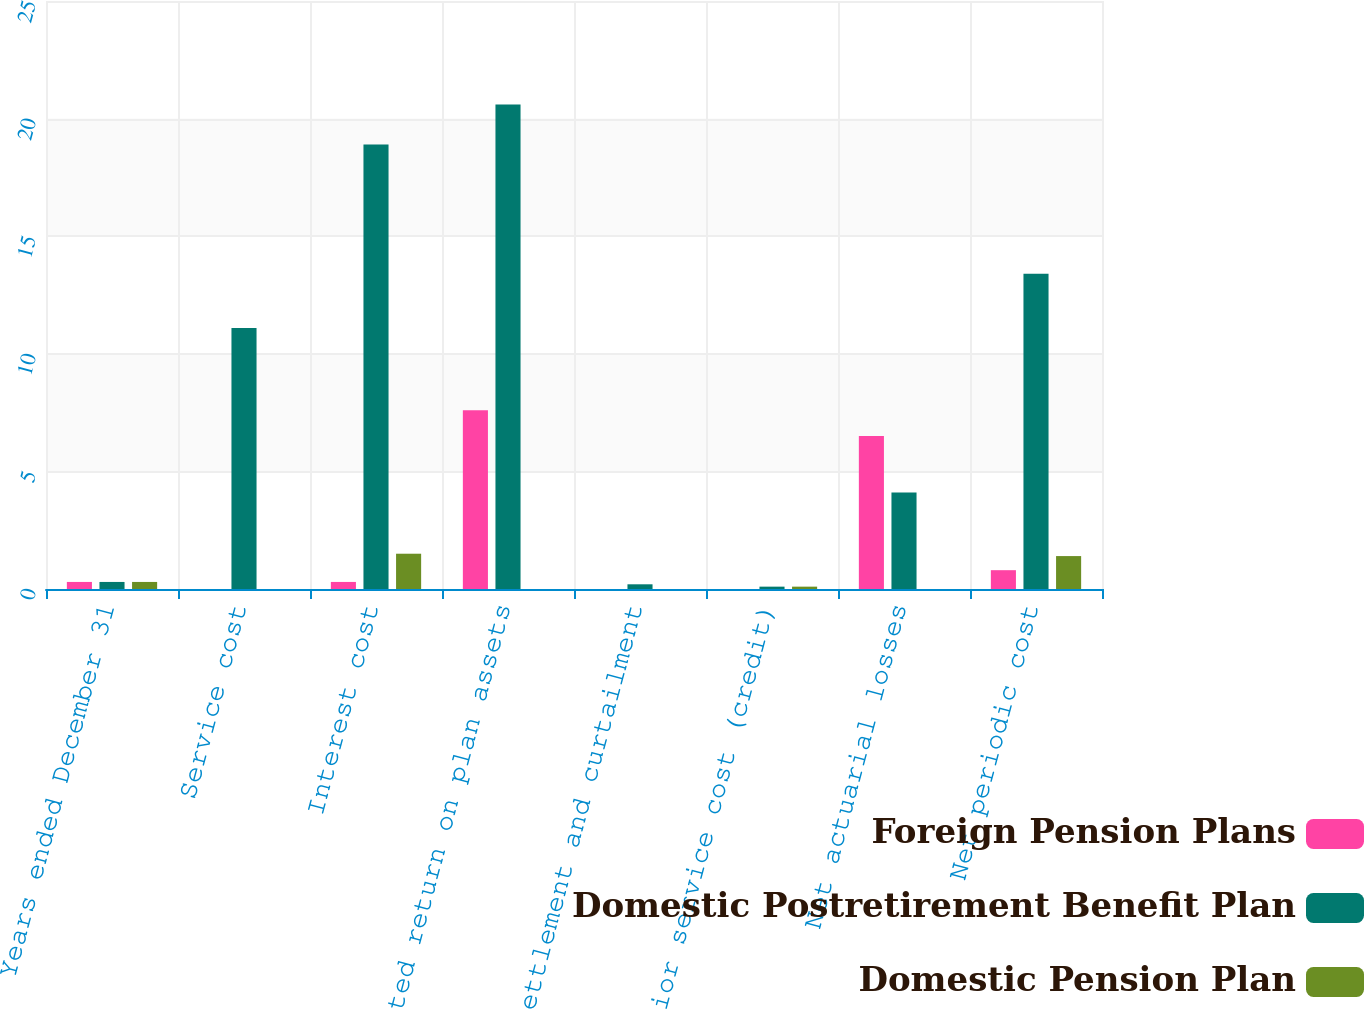<chart> <loc_0><loc_0><loc_500><loc_500><stacked_bar_chart><ecel><fcel>Years ended December 31<fcel>Service cost<fcel>Interest cost<fcel>Expected return on plan assets<fcel>Settlement and curtailment<fcel>Prior service cost (credit)<fcel>Net actuarial losses<fcel>Net periodic cost<nl><fcel>Foreign Pension Plans<fcel>0.3<fcel>0<fcel>0.3<fcel>7.6<fcel>0<fcel>0<fcel>6.5<fcel>0.8<nl><fcel>Domestic Postretirement Benefit Plan<fcel>0.3<fcel>11.1<fcel>18.9<fcel>20.6<fcel>0.2<fcel>0.1<fcel>4.1<fcel>13.4<nl><fcel>Domestic Pension Plan<fcel>0.3<fcel>0<fcel>1.5<fcel>0<fcel>0<fcel>0.1<fcel>0<fcel>1.4<nl></chart> 